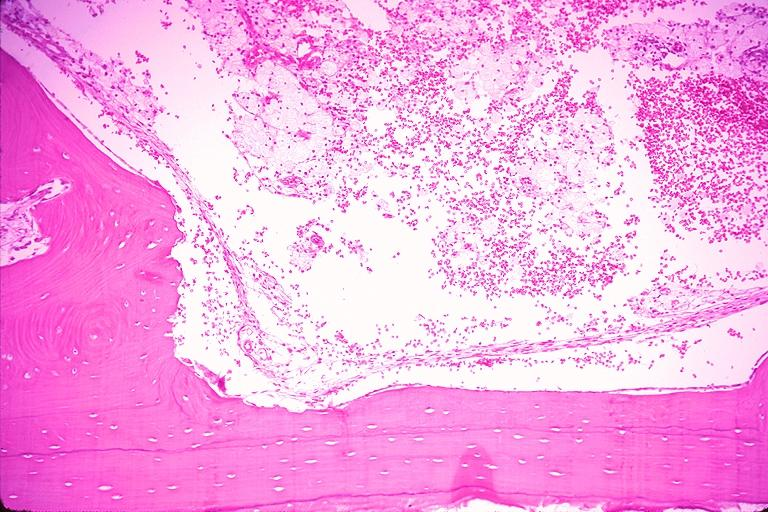what does this image show?
Answer the question using a single word or phrase. Traumatic bone cyst simple bone cyst 